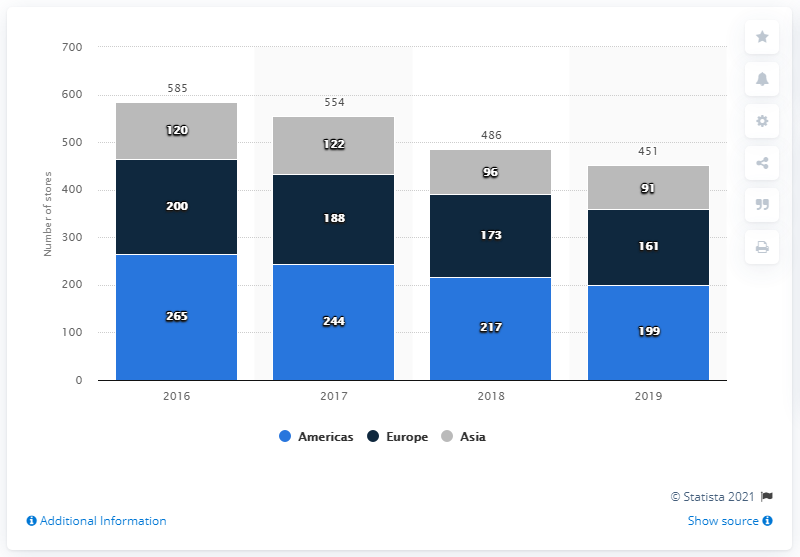List a handful of essential elements in this visual. In 2019, the Fossil Group operated 199 stores in the Americas. 